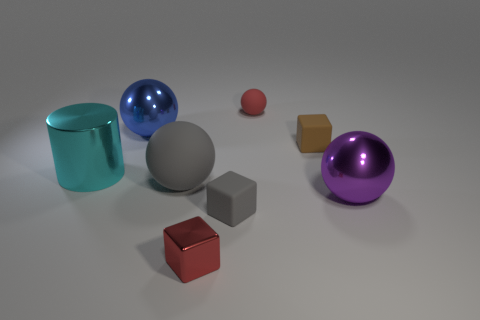Add 2 small rubber objects. How many objects exist? 10 Subtract all blocks. How many objects are left? 5 Add 2 big metallic cylinders. How many big metallic cylinders are left? 3 Add 4 small blue metal cubes. How many small blue metal cubes exist? 4 Subtract 1 gray balls. How many objects are left? 7 Subtract all small red rubber things. Subtract all tiny gray things. How many objects are left? 6 